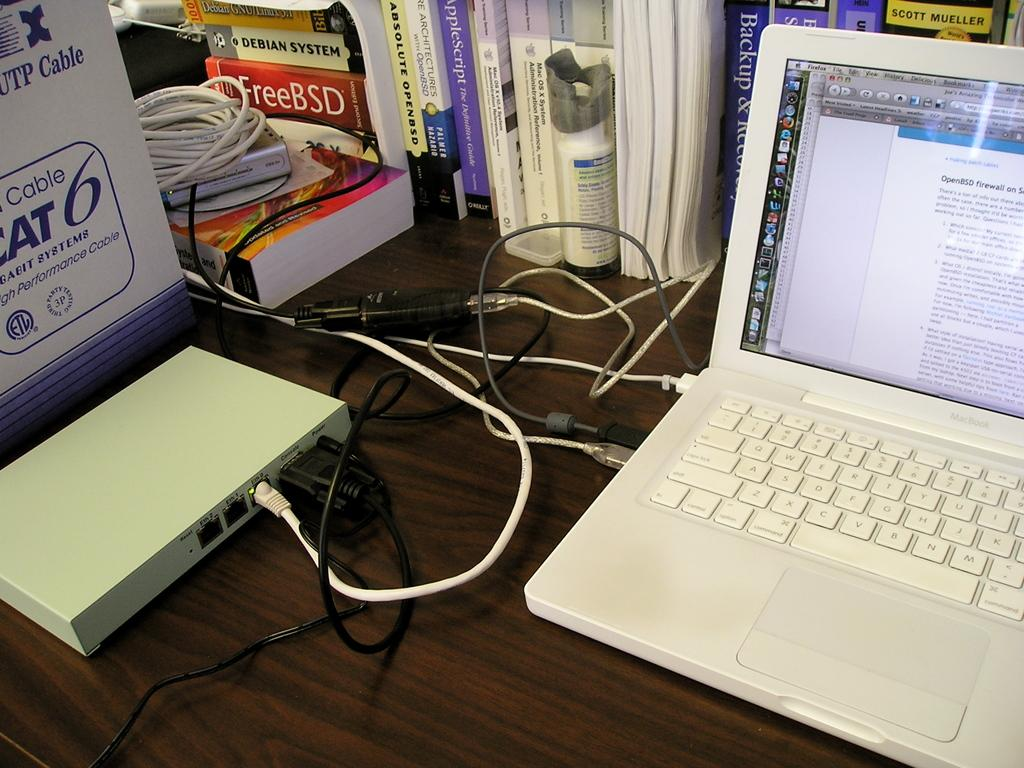Provide a one-sentence caption for the provided image. A Mac laptop has a screen open with information about OpenBSD firewalls. 